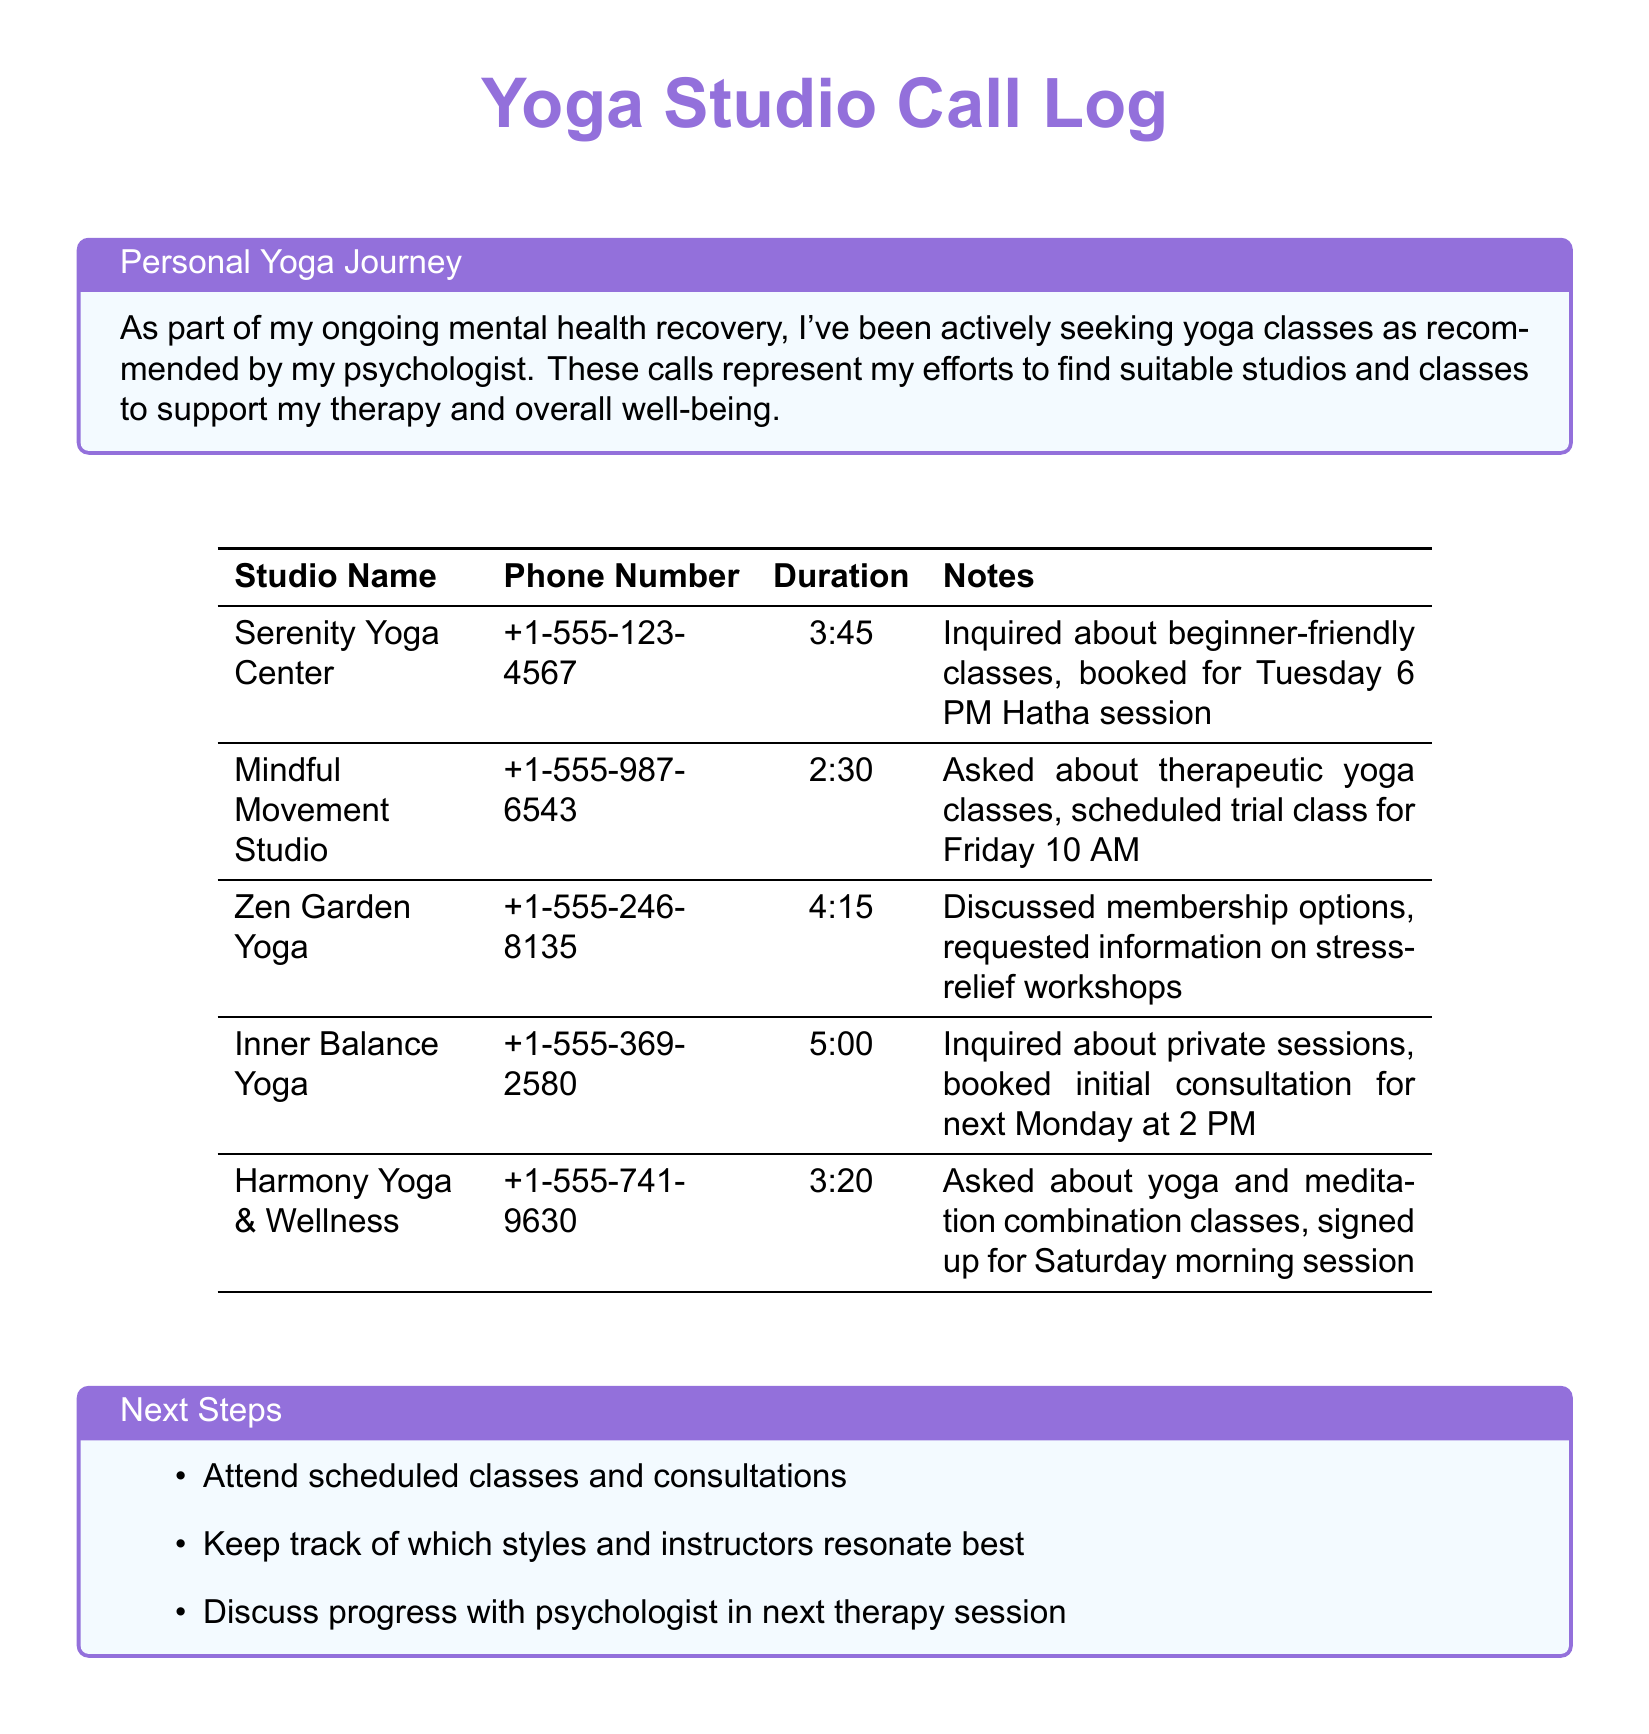What is the name of the first yoga studio? The first yoga studio listed in the document is Serenity Yoga Center.
Answer: Serenity Yoga Center What service was inquired about at Mindful Movement Studio? The inquiry made at Mindful Movement Studio was about therapeutic yoga classes.
Answer: Therapeutic yoga classes What was the duration of the call to Inner Balance Yoga? The duration of the call to Inner Balance Yoga was 5:00.
Answer: 5:00 What class was booked at Serenity Yoga Center? At Serenity Yoga Center, a Tuesday 6 PM Hatha session was booked.
Answer: Tuesday 6 PM Hatha session How many yoga studios are mentioned in the document? The document mentions a total of five yoga studios.
Answer: Five Which studio offered a combination of yoga and meditation classes? The studio that offered a combination of yoga and meditation classes is Harmony Yoga & Wellness.
Answer: Harmony Yoga & Wellness What was requested during the call to Zen Garden Yoga? The request during the call to Zen Garden Yoga was for information on stress-relief workshops.
Answer: Information on stress-relief workshops When is the initial consultation scheduled at Inner Balance Yoga? The initial consultation at Inner Balance Yoga is scheduled for next Monday at 2 PM.
Answer: Next Monday at 2 PM Which yoga studio was contacted for a trial class? The yoga studio contacted for a trial class is Mindful Movement Studio.
Answer: Mindful Movement Studio 